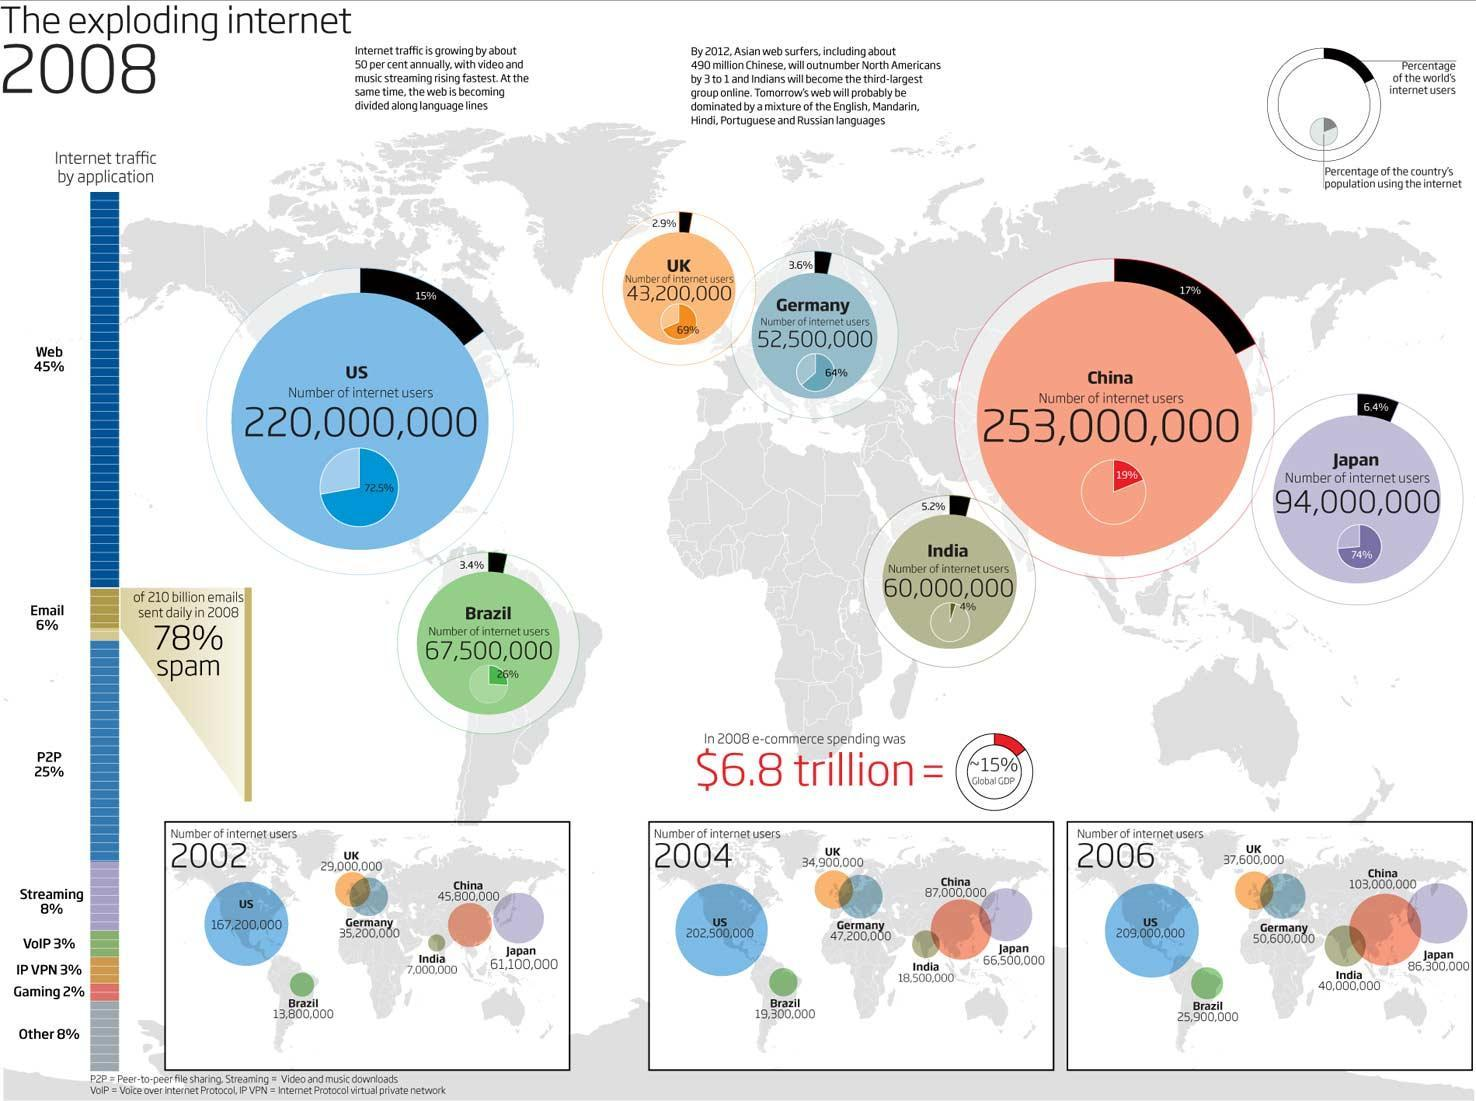of the 210 billion emails sent daily in 2008, what % is genuine and not span
Answer the question with a short phrase. 22 What is the total number of internet users in 2004 for countries shown in the Asian continent 172000000 What has been the increase in internet users in Brazil from 2004 to 2006 6600000 What % of the total worlds internet users is found in Germany and UK 6.5 What has been the total internet users in the countries shown in Europe in 2002 64200000 What % of internet traffic do emails and streaming cover 14 WHat % of Japan's population use internet 74% 